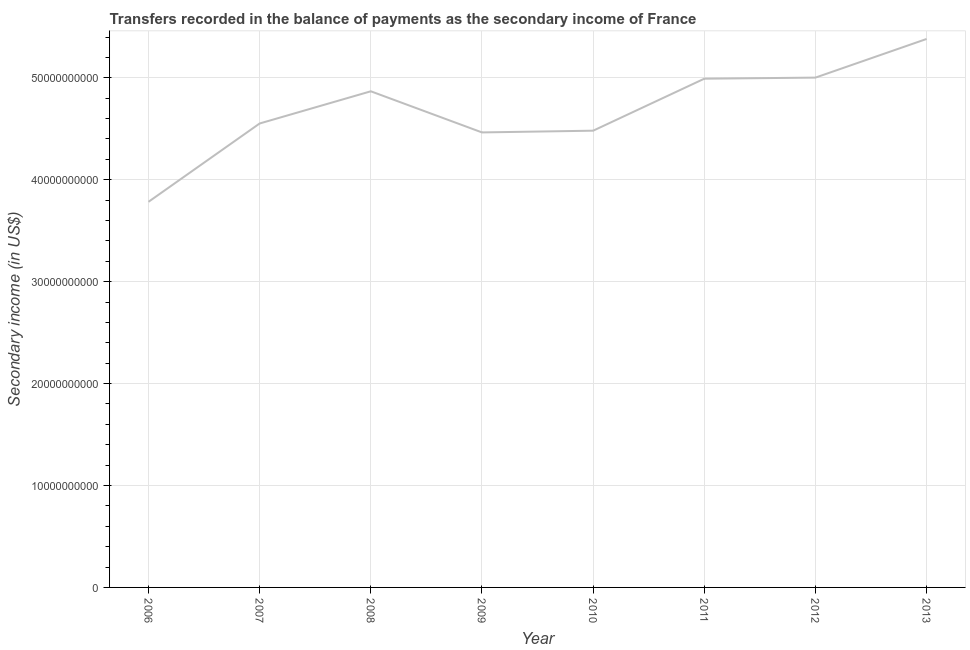What is the amount of secondary income in 2011?
Provide a short and direct response. 4.99e+1. Across all years, what is the maximum amount of secondary income?
Your answer should be very brief. 5.38e+1. Across all years, what is the minimum amount of secondary income?
Ensure brevity in your answer.  3.78e+1. In which year was the amount of secondary income maximum?
Provide a succinct answer. 2013. In which year was the amount of secondary income minimum?
Give a very brief answer. 2006. What is the sum of the amount of secondary income?
Your response must be concise. 3.75e+11. What is the difference between the amount of secondary income in 2008 and 2011?
Your response must be concise. -1.23e+09. What is the average amount of secondary income per year?
Provide a succinct answer. 4.69e+1. What is the median amount of secondary income?
Your response must be concise. 4.71e+1. What is the ratio of the amount of secondary income in 2010 to that in 2012?
Provide a succinct answer. 0.9. Is the amount of secondary income in 2007 less than that in 2013?
Provide a short and direct response. Yes. What is the difference between the highest and the second highest amount of secondary income?
Provide a succinct answer. 3.79e+09. Is the sum of the amount of secondary income in 2011 and 2012 greater than the maximum amount of secondary income across all years?
Provide a succinct answer. Yes. What is the difference between the highest and the lowest amount of secondary income?
Provide a short and direct response. 1.60e+1. How many lines are there?
Give a very brief answer. 1. Does the graph contain any zero values?
Ensure brevity in your answer.  No. Does the graph contain grids?
Your answer should be very brief. Yes. What is the title of the graph?
Provide a short and direct response. Transfers recorded in the balance of payments as the secondary income of France. What is the label or title of the X-axis?
Ensure brevity in your answer.  Year. What is the label or title of the Y-axis?
Offer a terse response. Secondary income (in US$). What is the Secondary income (in US$) of 2006?
Provide a succinct answer. 3.78e+1. What is the Secondary income (in US$) of 2007?
Your response must be concise. 4.55e+1. What is the Secondary income (in US$) in 2008?
Your response must be concise. 4.87e+1. What is the Secondary income (in US$) of 2009?
Your response must be concise. 4.46e+1. What is the Secondary income (in US$) in 2010?
Keep it short and to the point. 4.48e+1. What is the Secondary income (in US$) of 2011?
Your response must be concise. 4.99e+1. What is the Secondary income (in US$) of 2012?
Provide a succinct answer. 5.00e+1. What is the Secondary income (in US$) in 2013?
Make the answer very short. 5.38e+1. What is the difference between the Secondary income (in US$) in 2006 and 2007?
Make the answer very short. -7.69e+09. What is the difference between the Secondary income (in US$) in 2006 and 2008?
Give a very brief answer. -1.08e+1. What is the difference between the Secondary income (in US$) in 2006 and 2009?
Provide a succinct answer. -6.81e+09. What is the difference between the Secondary income (in US$) in 2006 and 2010?
Your response must be concise. -6.98e+09. What is the difference between the Secondary income (in US$) in 2006 and 2011?
Ensure brevity in your answer.  -1.21e+1. What is the difference between the Secondary income (in US$) in 2006 and 2012?
Ensure brevity in your answer.  -1.22e+1. What is the difference between the Secondary income (in US$) in 2006 and 2013?
Your answer should be very brief. -1.60e+1. What is the difference between the Secondary income (in US$) in 2007 and 2008?
Make the answer very short. -3.16e+09. What is the difference between the Secondary income (in US$) in 2007 and 2009?
Ensure brevity in your answer.  8.78e+08. What is the difference between the Secondary income (in US$) in 2007 and 2010?
Your response must be concise. 7.08e+08. What is the difference between the Secondary income (in US$) in 2007 and 2011?
Give a very brief answer. -4.39e+09. What is the difference between the Secondary income (in US$) in 2007 and 2012?
Offer a terse response. -4.50e+09. What is the difference between the Secondary income (in US$) in 2007 and 2013?
Keep it short and to the point. -8.29e+09. What is the difference between the Secondary income (in US$) in 2008 and 2009?
Provide a succinct answer. 4.04e+09. What is the difference between the Secondary income (in US$) in 2008 and 2010?
Provide a succinct answer. 3.86e+09. What is the difference between the Secondary income (in US$) in 2008 and 2011?
Your answer should be very brief. -1.23e+09. What is the difference between the Secondary income (in US$) in 2008 and 2012?
Offer a very short reply. -1.34e+09. What is the difference between the Secondary income (in US$) in 2008 and 2013?
Ensure brevity in your answer.  -5.13e+09. What is the difference between the Secondary income (in US$) in 2009 and 2010?
Keep it short and to the point. -1.71e+08. What is the difference between the Secondary income (in US$) in 2009 and 2011?
Your response must be concise. -5.27e+09. What is the difference between the Secondary income (in US$) in 2009 and 2012?
Give a very brief answer. -5.38e+09. What is the difference between the Secondary income (in US$) in 2009 and 2013?
Your response must be concise. -9.17e+09. What is the difference between the Secondary income (in US$) in 2010 and 2011?
Provide a succinct answer. -5.10e+09. What is the difference between the Secondary income (in US$) in 2010 and 2012?
Make the answer very short. -5.21e+09. What is the difference between the Secondary income (in US$) in 2010 and 2013?
Your answer should be compact. -9.00e+09. What is the difference between the Secondary income (in US$) in 2011 and 2012?
Make the answer very short. -1.08e+08. What is the difference between the Secondary income (in US$) in 2011 and 2013?
Give a very brief answer. -3.90e+09. What is the difference between the Secondary income (in US$) in 2012 and 2013?
Your answer should be compact. -3.79e+09. What is the ratio of the Secondary income (in US$) in 2006 to that in 2007?
Provide a short and direct response. 0.83. What is the ratio of the Secondary income (in US$) in 2006 to that in 2008?
Your response must be concise. 0.78. What is the ratio of the Secondary income (in US$) in 2006 to that in 2009?
Provide a short and direct response. 0.85. What is the ratio of the Secondary income (in US$) in 2006 to that in 2010?
Your answer should be very brief. 0.84. What is the ratio of the Secondary income (in US$) in 2006 to that in 2011?
Make the answer very short. 0.76. What is the ratio of the Secondary income (in US$) in 2006 to that in 2012?
Offer a terse response. 0.76. What is the ratio of the Secondary income (in US$) in 2006 to that in 2013?
Make the answer very short. 0.7. What is the ratio of the Secondary income (in US$) in 2007 to that in 2008?
Offer a terse response. 0.94. What is the ratio of the Secondary income (in US$) in 2007 to that in 2009?
Give a very brief answer. 1.02. What is the ratio of the Secondary income (in US$) in 2007 to that in 2010?
Offer a terse response. 1.02. What is the ratio of the Secondary income (in US$) in 2007 to that in 2011?
Ensure brevity in your answer.  0.91. What is the ratio of the Secondary income (in US$) in 2007 to that in 2012?
Provide a succinct answer. 0.91. What is the ratio of the Secondary income (in US$) in 2007 to that in 2013?
Your answer should be very brief. 0.85. What is the ratio of the Secondary income (in US$) in 2008 to that in 2009?
Keep it short and to the point. 1.09. What is the ratio of the Secondary income (in US$) in 2008 to that in 2010?
Your response must be concise. 1.09. What is the ratio of the Secondary income (in US$) in 2008 to that in 2011?
Your answer should be very brief. 0.97. What is the ratio of the Secondary income (in US$) in 2008 to that in 2012?
Your answer should be compact. 0.97. What is the ratio of the Secondary income (in US$) in 2008 to that in 2013?
Your answer should be compact. 0.91. What is the ratio of the Secondary income (in US$) in 2009 to that in 2010?
Offer a very short reply. 1. What is the ratio of the Secondary income (in US$) in 2009 to that in 2011?
Your answer should be compact. 0.89. What is the ratio of the Secondary income (in US$) in 2009 to that in 2012?
Ensure brevity in your answer.  0.89. What is the ratio of the Secondary income (in US$) in 2009 to that in 2013?
Ensure brevity in your answer.  0.83. What is the ratio of the Secondary income (in US$) in 2010 to that in 2011?
Offer a terse response. 0.9. What is the ratio of the Secondary income (in US$) in 2010 to that in 2012?
Offer a terse response. 0.9. What is the ratio of the Secondary income (in US$) in 2010 to that in 2013?
Provide a short and direct response. 0.83. What is the ratio of the Secondary income (in US$) in 2011 to that in 2013?
Provide a short and direct response. 0.93. What is the ratio of the Secondary income (in US$) in 2012 to that in 2013?
Your answer should be very brief. 0.93. 